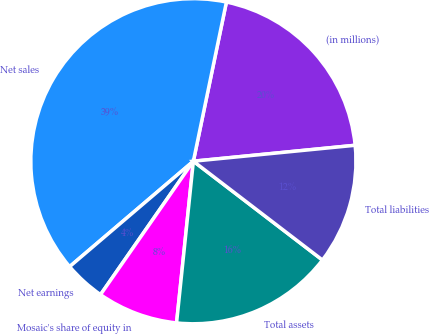Convert chart. <chart><loc_0><loc_0><loc_500><loc_500><pie_chart><fcel>(in millions)<fcel>Net sales<fcel>Net earnings<fcel>Mosaic's share of equity in<fcel>Total assets<fcel>Total liabilities<nl><fcel>20.18%<fcel>39.49%<fcel>4.09%<fcel>8.03%<fcel>16.25%<fcel>11.96%<nl></chart> 